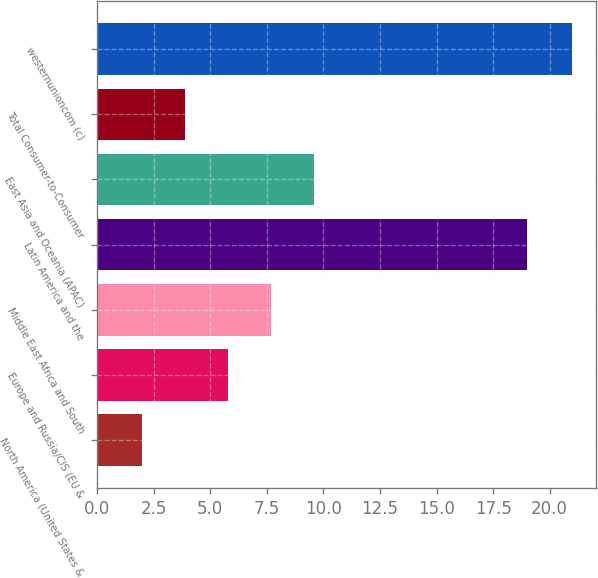Convert chart to OTSL. <chart><loc_0><loc_0><loc_500><loc_500><bar_chart><fcel>North America (United States &<fcel>Europe and Russia/CIS (EU &<fcel>Middle East Africa and South<fcel>Latin America and the<fcel>East Asia and Oceania (APAC)<fcel>Total Consumer-to-Consumer<fcel>westernunioncom (c)<nl><fcel>2<fcel>5.8<fcel>7.7<fcel>19<fcel>9.6<fcel>3.9<fcel>21<nl></chart> 